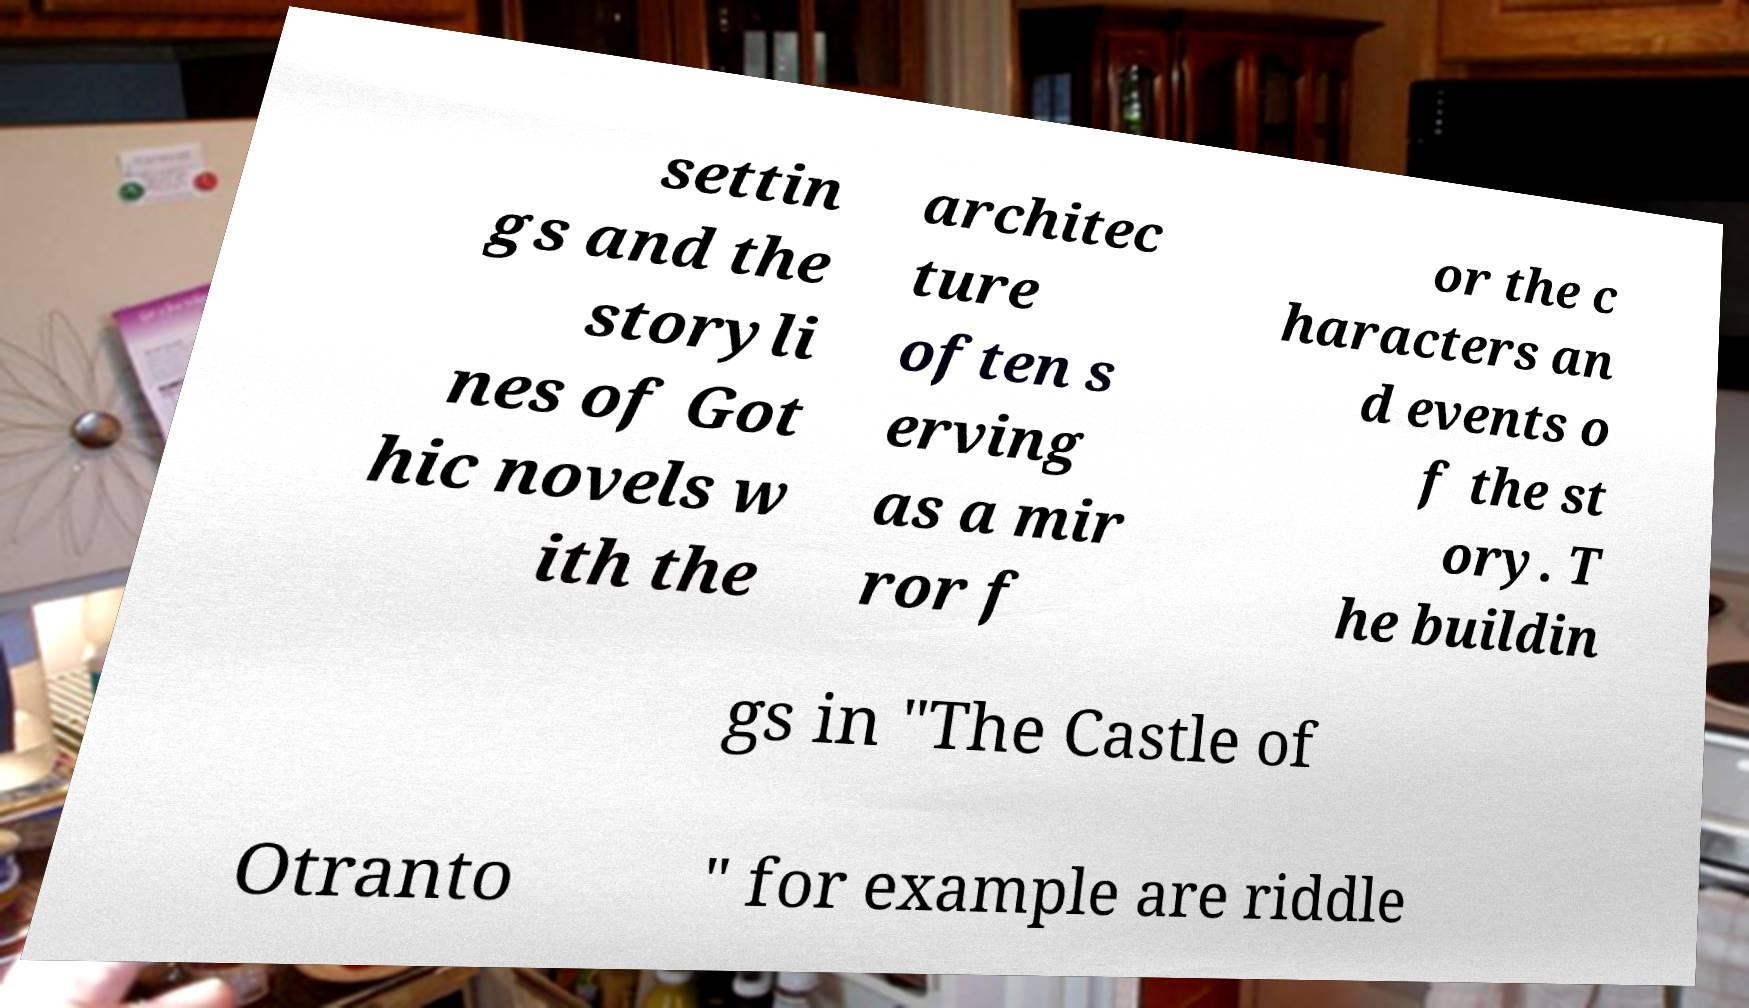Could you assist in decoding the text presented in this image and type it out clearly? settin gs and the storyli nes of Got hic novels w ith the architec ture often s erving as a mir ror f or the c haracters an d events o f the st ory. T he buildin gs in "The Castle of Otranto " for example are riddle 